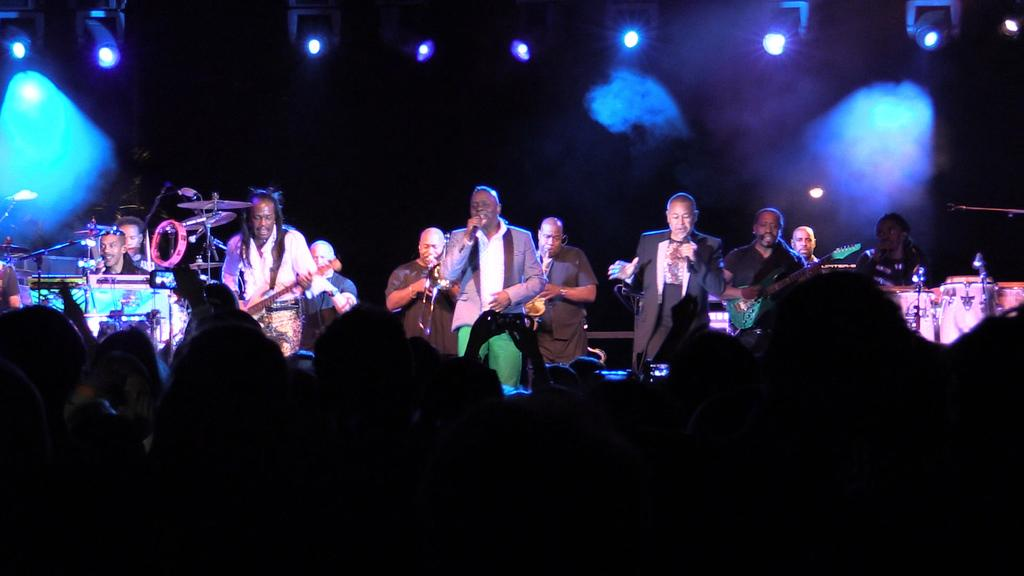What are the people in the foreground of the image doing? The people in the foreground of the image are holding mobile devices. What can be seen in the middle of the image? There are people performing activities in the middle of the image. What type of organization is depicted in the image? There is no organization depicted in the image; it features people holding mobile devices and performing activities. Can you tell me how many boots are visible in the image? There are no boots present in the image. 